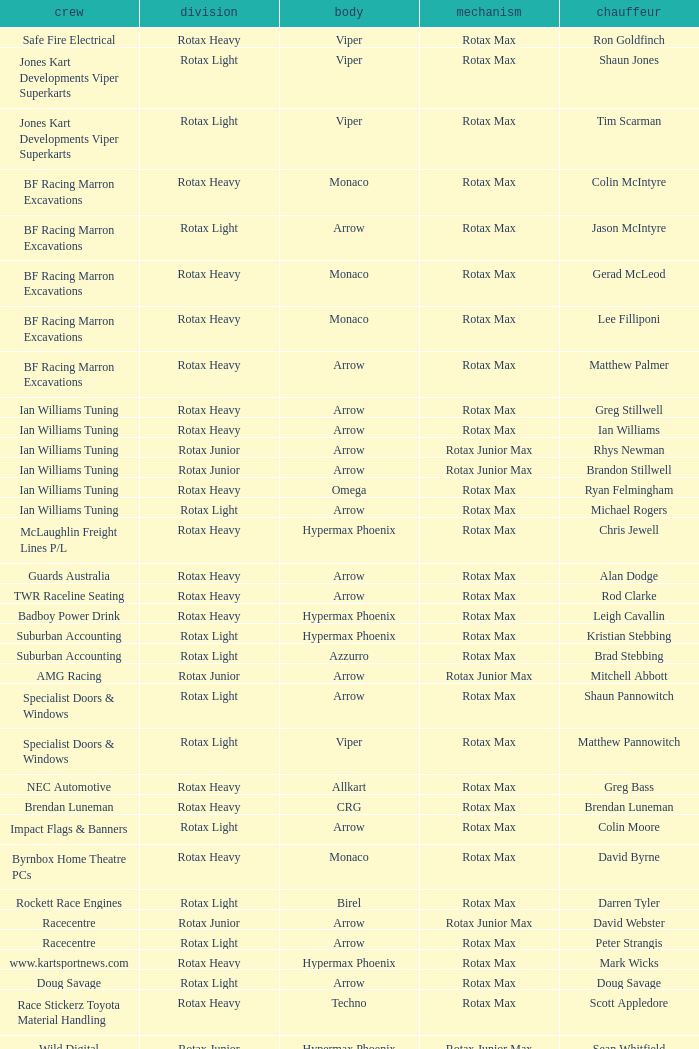What is the name of the driver with a rotax max engine, in the rotax heavy class, with arrow as chassis and on the TWR Raceline Seating team? Rod Clarke. 